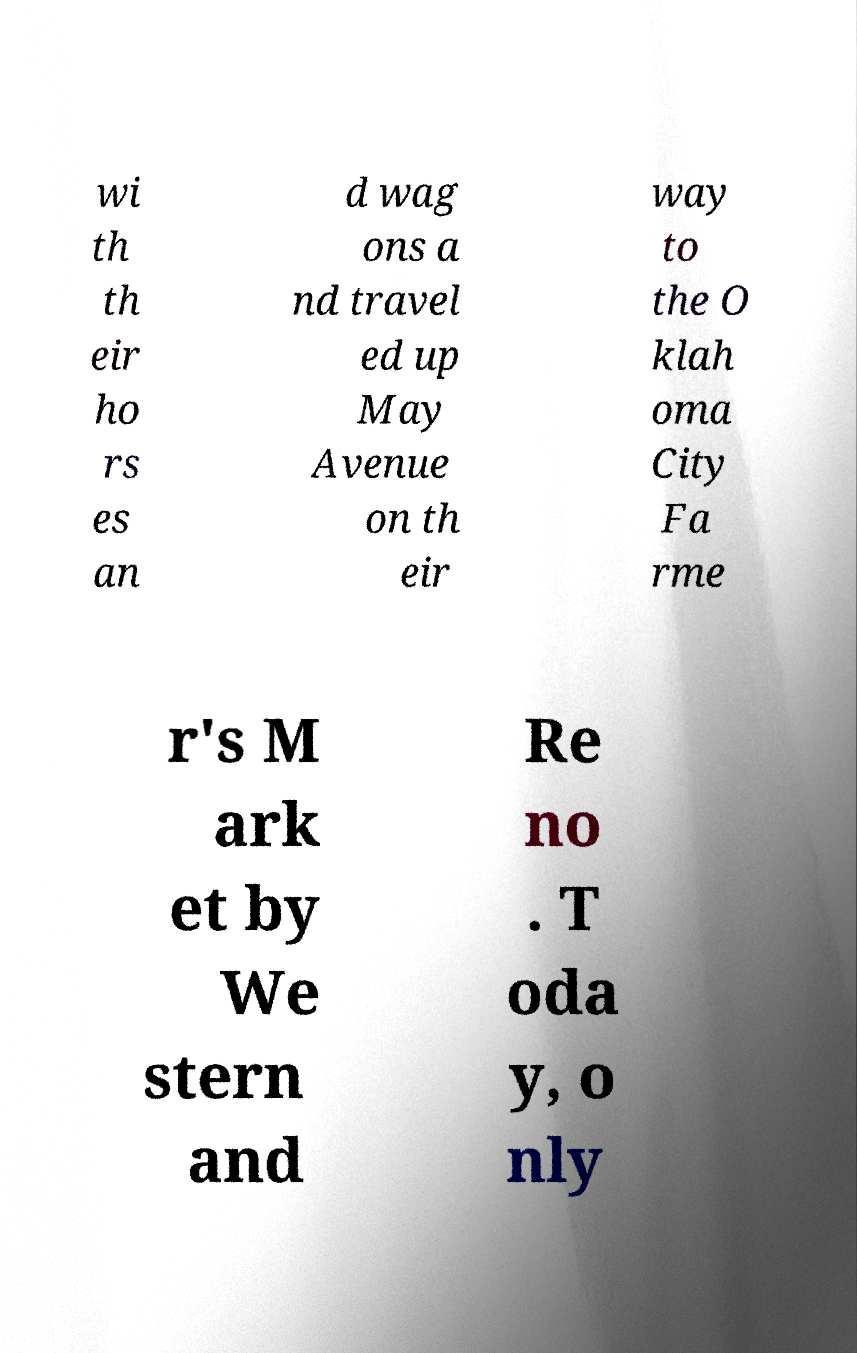Please read and relay the text visible in this image. What does it say? wi th th eir ho rs es an d wag ons a nd travel ed up May Avenue on th eir way to the O klah oma City Fa rme r's M ark et by We stern and Re no . T oda y, o nly 